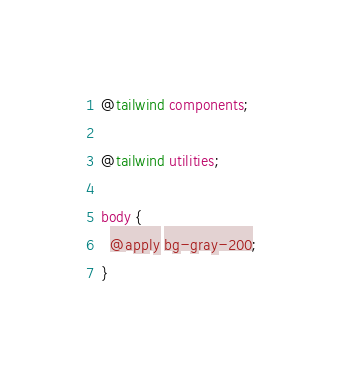Convert code to text. <code><loc_0><loc_0><loc_500><loc_500><_CSS_>
@tailwind components;

@tailwind utilities;

body {
  @apply bg-gray-200;
}
</code> 